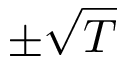Convert formula to latex. <formula><loc_0><loc_0><loc_500><loc_500>\pm \sqrt { T }</formula> 